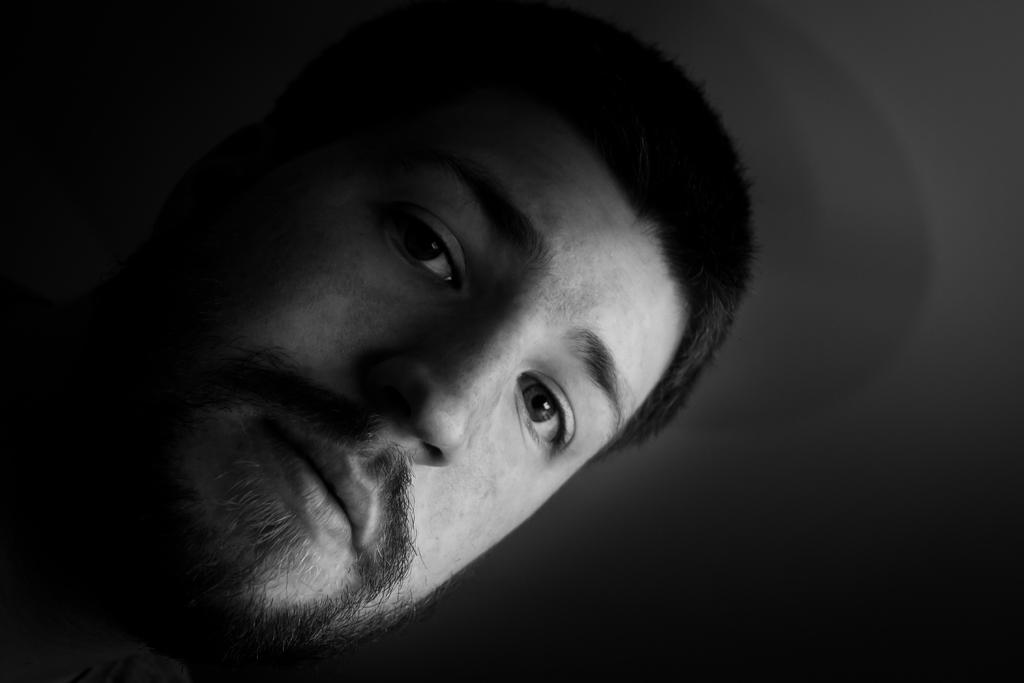What is the color scheme of the image? The image is black and white. What is the main subject of the image? There is a human face in the center of the image. What type of frame surrounds the human face in the image? There is no frame surrounding the human face in the image, as it is a black and white photograph with a central focus on the face. Can you see any steam coming from the human face in the image? There is no steam present in the image, as it is a black and white photograph of a human face. 